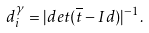<formula> <loc_0><loc_0><loc_500><loc_500>d ^ { \gamma } _ { i } = | d e t ( \overline { t } - I d ) | ^ { - 1 } .</formula> 